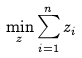<formula> <loc_0><loc_0><loc_500><loc_500>\min _ { z } \sum _ { i = 1 } ^ { n } { z _ { i } }</formula> 